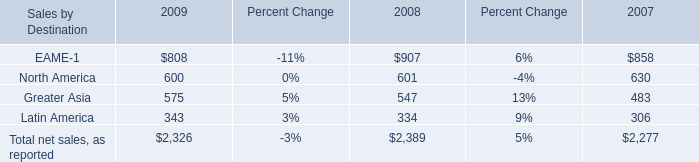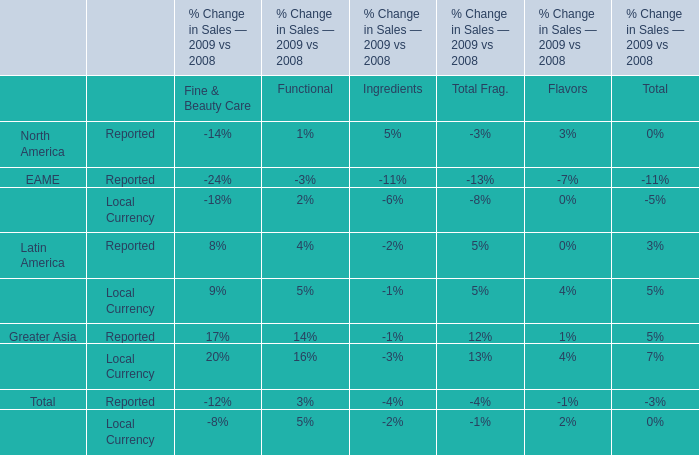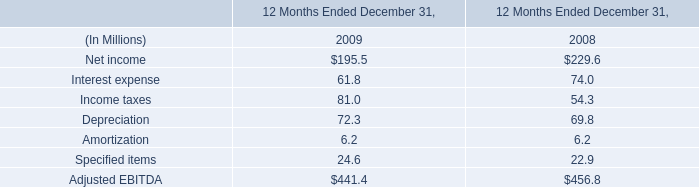Which year is net sales, as reported for Sales by Destination Greater Asia the highest? 
Answer: 2009. 